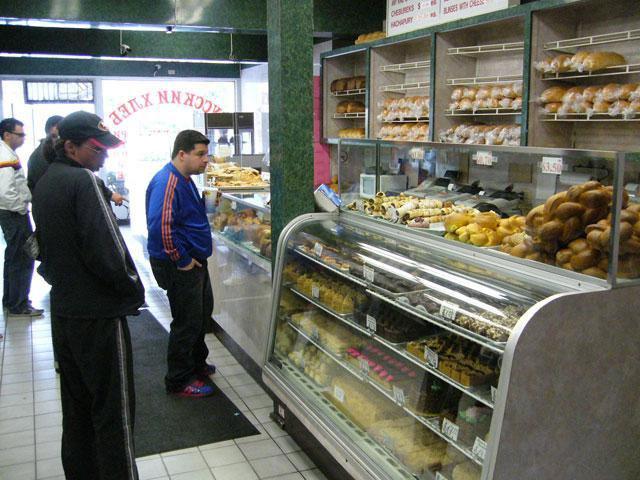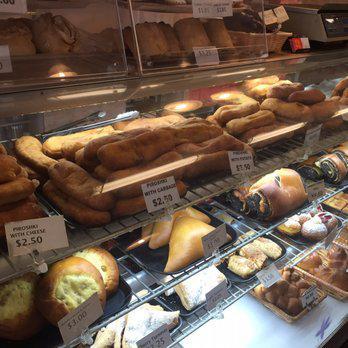The first image is the image on the left, the second image is the image on the right. Analyze the images presented: Is the assertion "Windows can be seen in the image on the left." valid? Answer yes or no. Yes. 